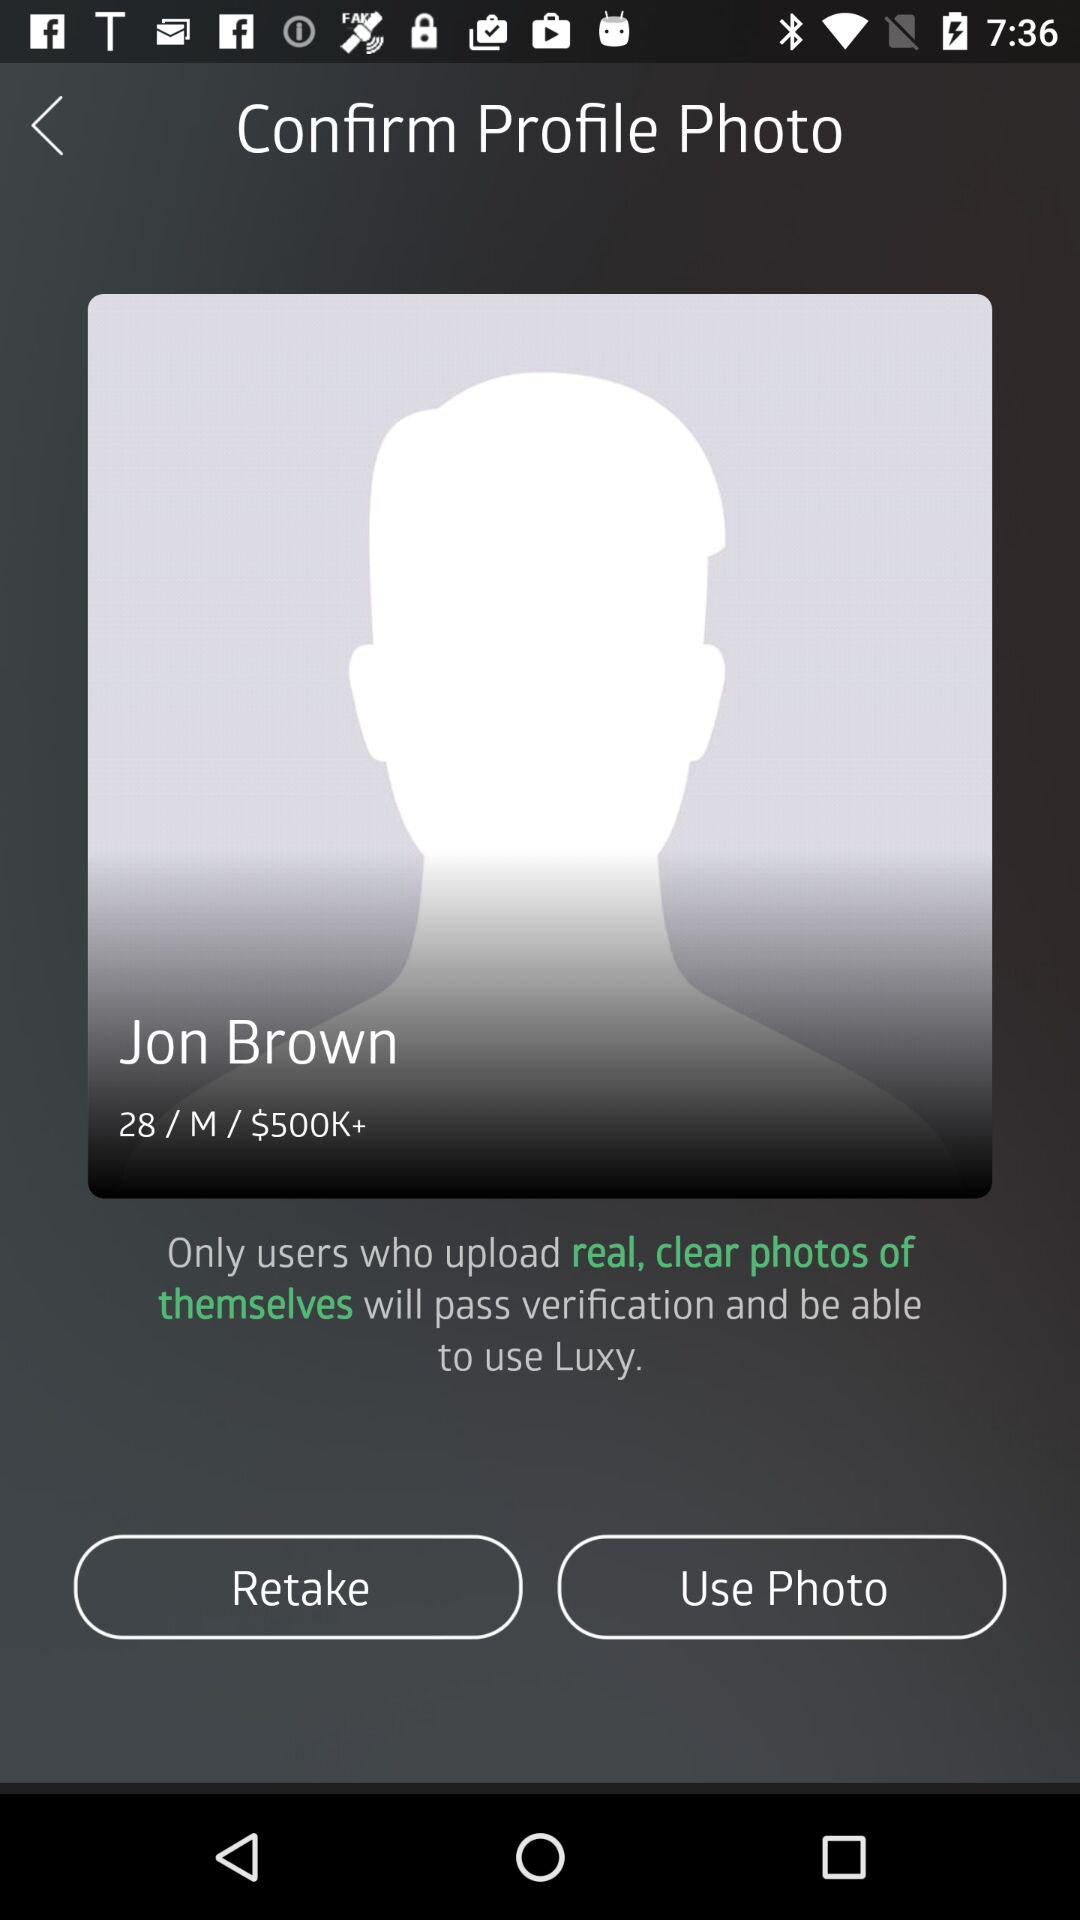What is the age of Jon Brown? The age of Jon Brown is 28 years. 